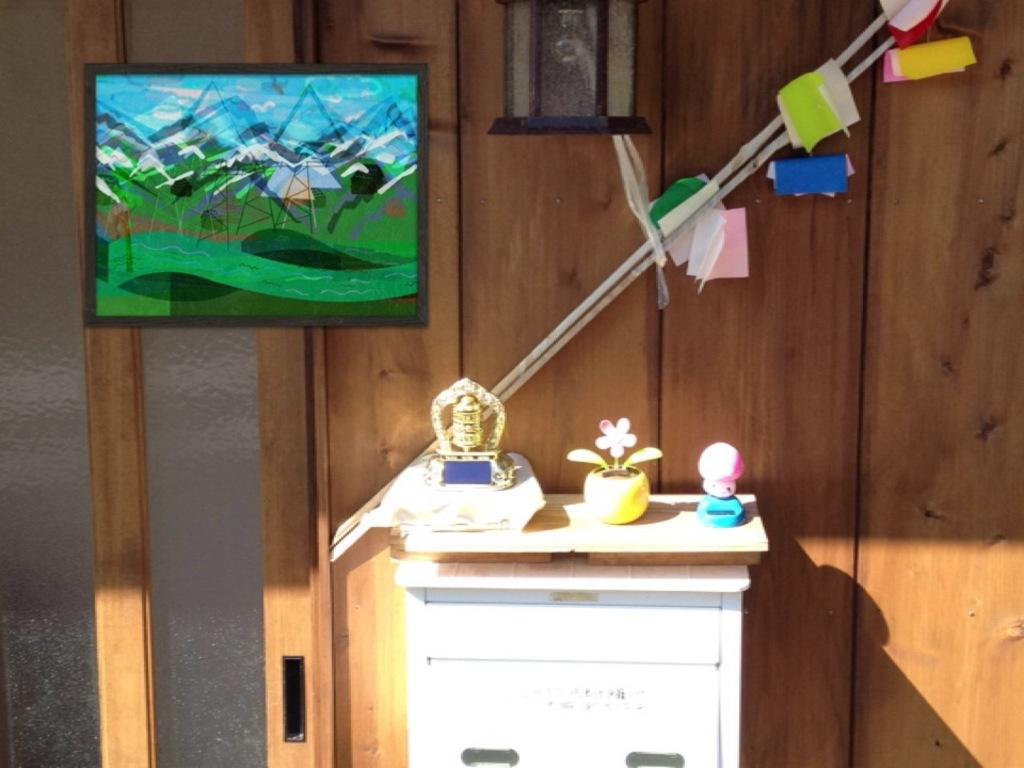What is the main piece of furniture in the image? There is a table in the image. What objects can be seen on the table? There is a toy and a flower pot on the table. Are there any other items on the table? Yes, there are some items on the table. What can be seen in the background of the image? There is a wall, a frame, sticks, and papers in the background of the image. What type of carriage is visible in the background of the image? There is no carriage present in the image. How does the division between the wall and the frame affect the overall composition of the image? The image does not mention any division between the wall and the frame, so it is not possible to answer this question. 